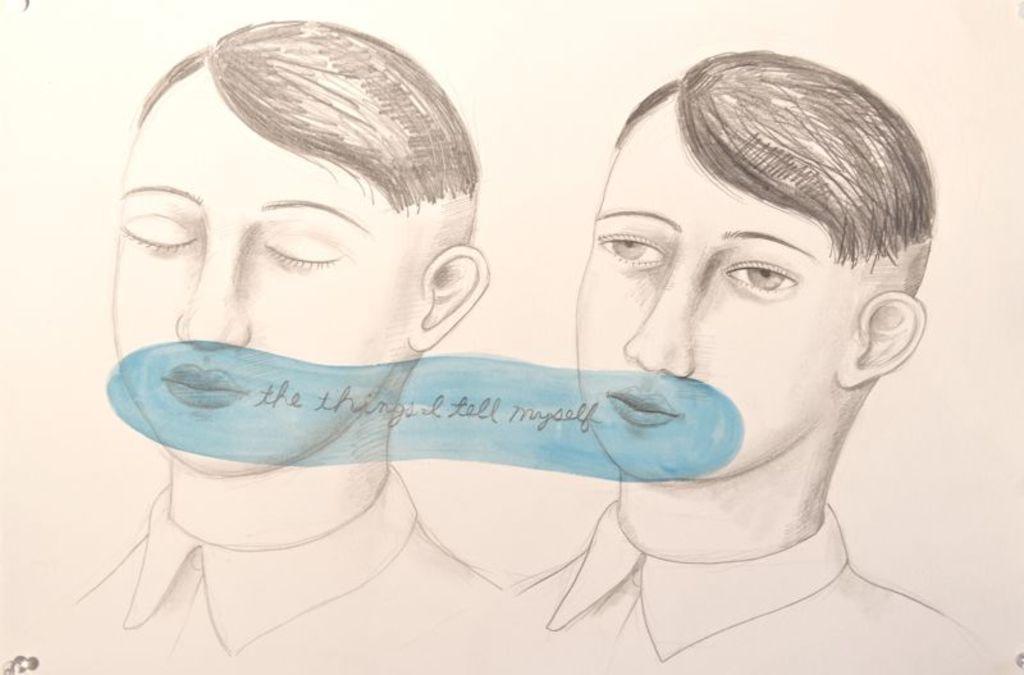Please provide a concise description of this image. In this picture we can see pencil drawing of two persons. Here we can see something is returned on the blue color object. 